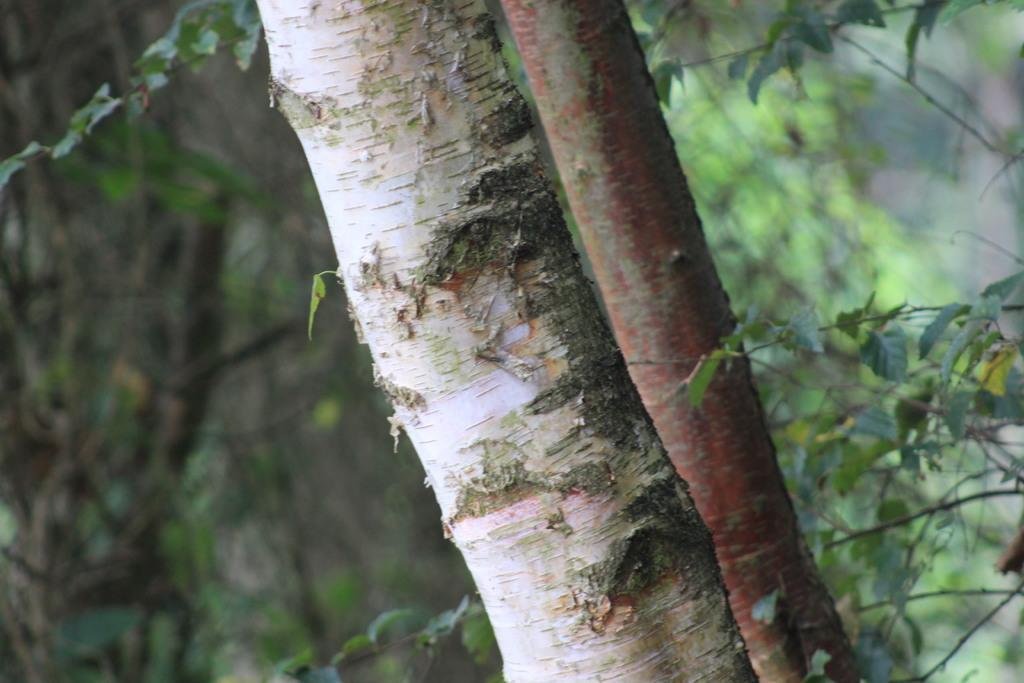What object is the main focus of the image? There is a trunk in the image. What can be seen in the background of the image? There are trees in the background of the image. What color are the trees in the image? The trees are green in color. What type of grape is being added to the trunk in the image? There is no grape present in the image, and no addition is taking place. 